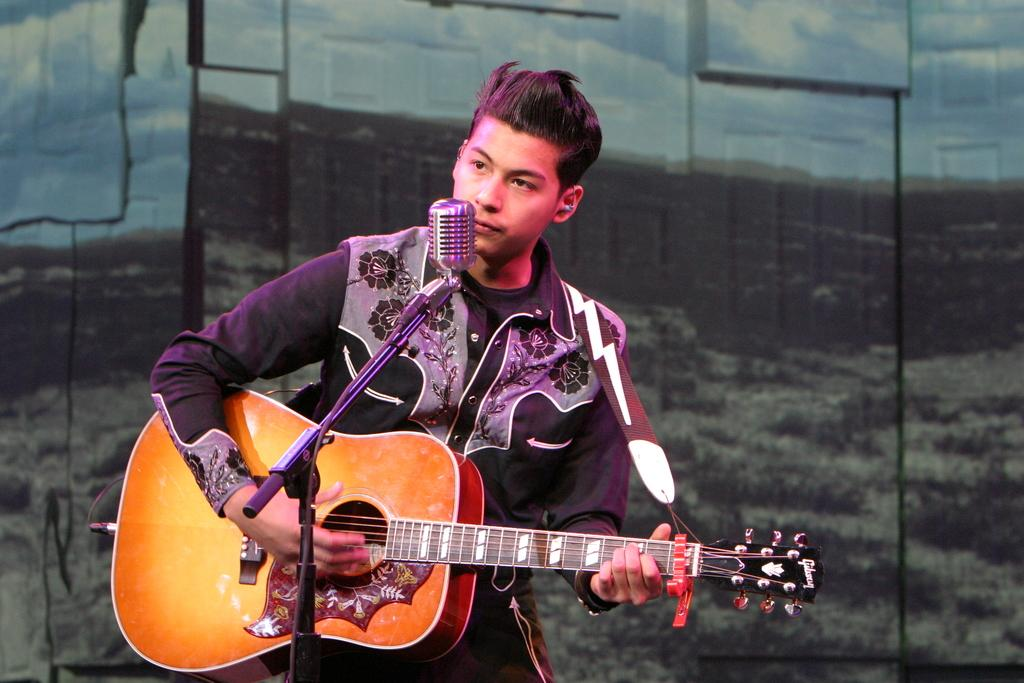Who is the main subject in the image? There is a man in the image. What is the man doing in the image? The man is standing in front of a microphone and playing a guitar. What type of magic is the man performing with the grass in the image? There is no grass present in the image, and the man is not performing any magic. 